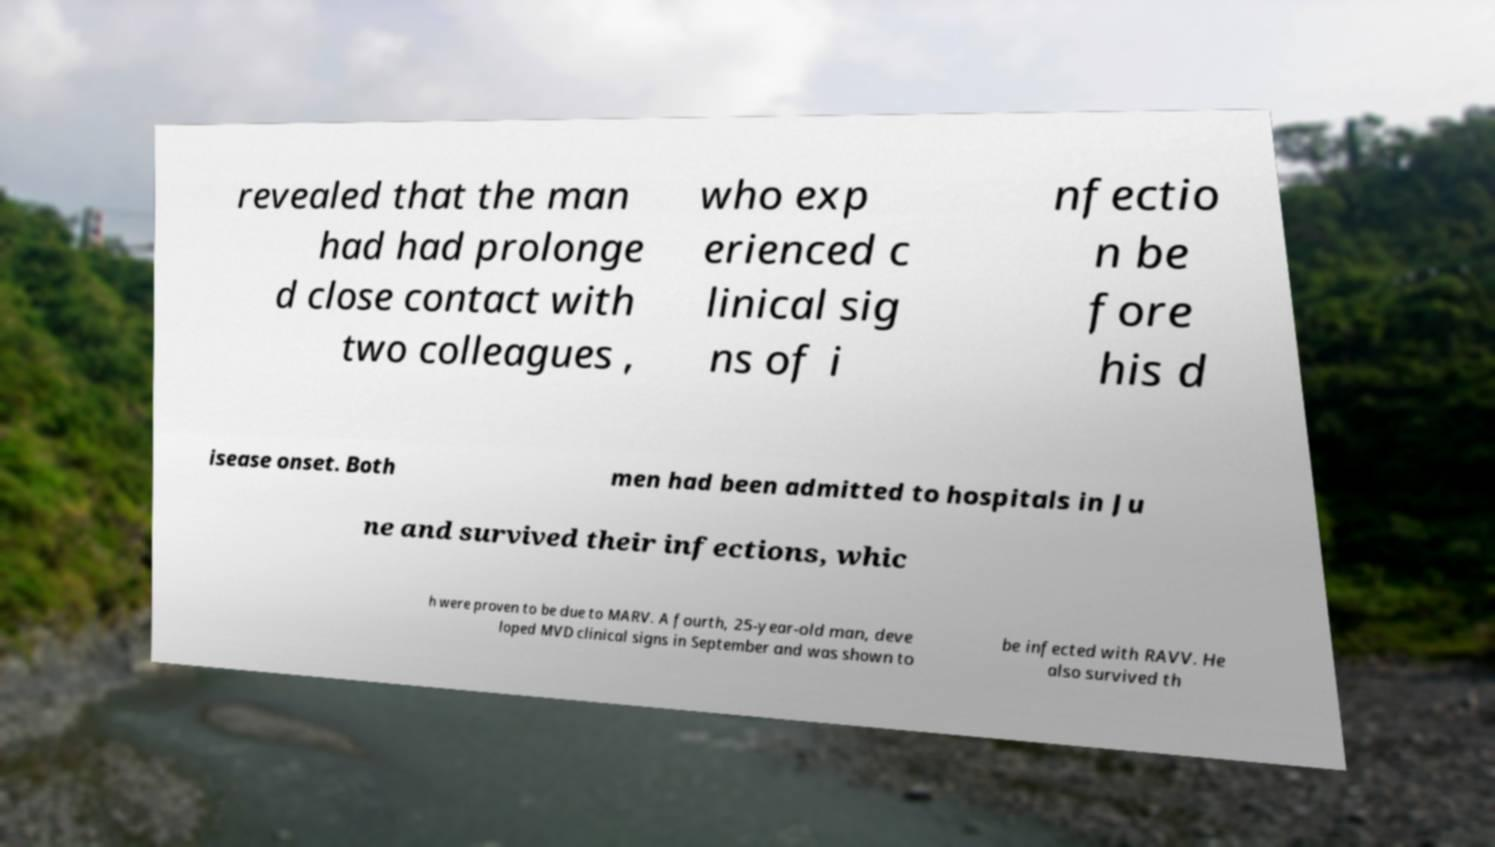Please identify and transcribe the text found in this image. revealed that the man had had prolonge d close contact with two colleagues , who exp erienced c linical sig ns of i nfectio n be fore his d isease onset. Both men had been admitted to hospitals in Ju ne and survived their infections, whic h were proven to be due to MARV. A fourth, 25-year-old man, deve loped MVD clinical signs in September and was shown to be infected with RAVV. He also survived th 